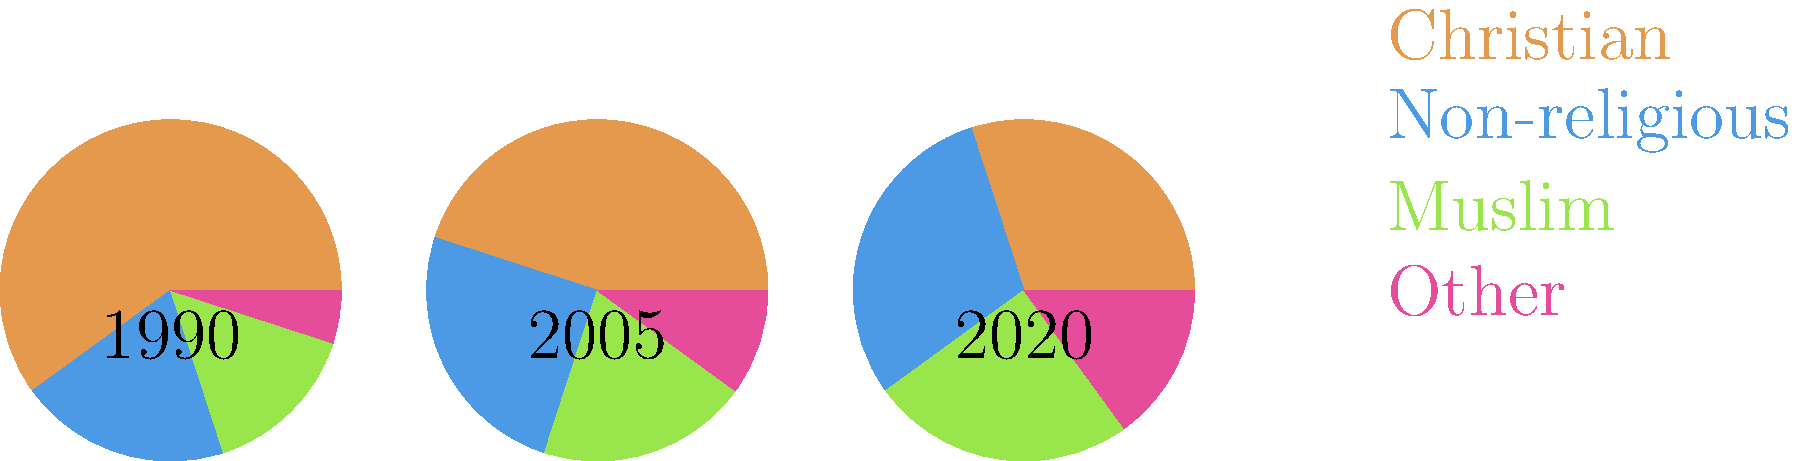Based on the pie charts showing the change in religious demographics from 1990 to 2020, which religious group has shown the most significant increase in percentage, and how might this affect community cohesion in the neighborhood? To answer this question, we need to analyze the pie charts and compare the percentages for each religious group across the three time periods:

1. Christian:
   1990: 60%, 2005: 45%, 2020: 30%
   Trend: Decreasing

2. Non-religious:
   1990: 20%, 2005: 25%, 2020: 30%
   Trend: Increasing

3. Muslim:
   1990: 15%, 2005: 20%, 2020: 25%
   Trend: Increasing

4. Other:
   1990: 5%, 2005: 10%, 2020: 15%
   Trend: Increasing

The group with the most significant increase in percentage is the Muslim population, which has grown from 15% in 1990 to 25% in 2020, a 10 percentage point increase.

Regarding community cohesion:

1. Increased diversity can lead to a more vibrant community with various cultural perspectives and practices.
2. However, it may also create challenges in terms of integrating different religious practices and customs.
3. The decrease in the Christian majority might lead to changes in longstanding community traditions.
4. The rise in non-religious individuals could impact community events centered around religious practices.
5. Potential for misunderstandings or conflicts if there's a lack of inter-faith dialogue and education.
6. Opportunities for fostering inclusivity and mutual understanding through community events and programs.

To maintain community cohesion, it would be important to:
1. Promote interfaith dialogue and understanding
2. Organize inclusive community events that celebrate diversity
3. Ensure equal representation in community decision-making processes
4. Address concerns and potential conflicts proactively through open communication
Answer: Muslim population; increased diversity may challenge traditional community practices, requiring proactive measures to maintain cohesion. 